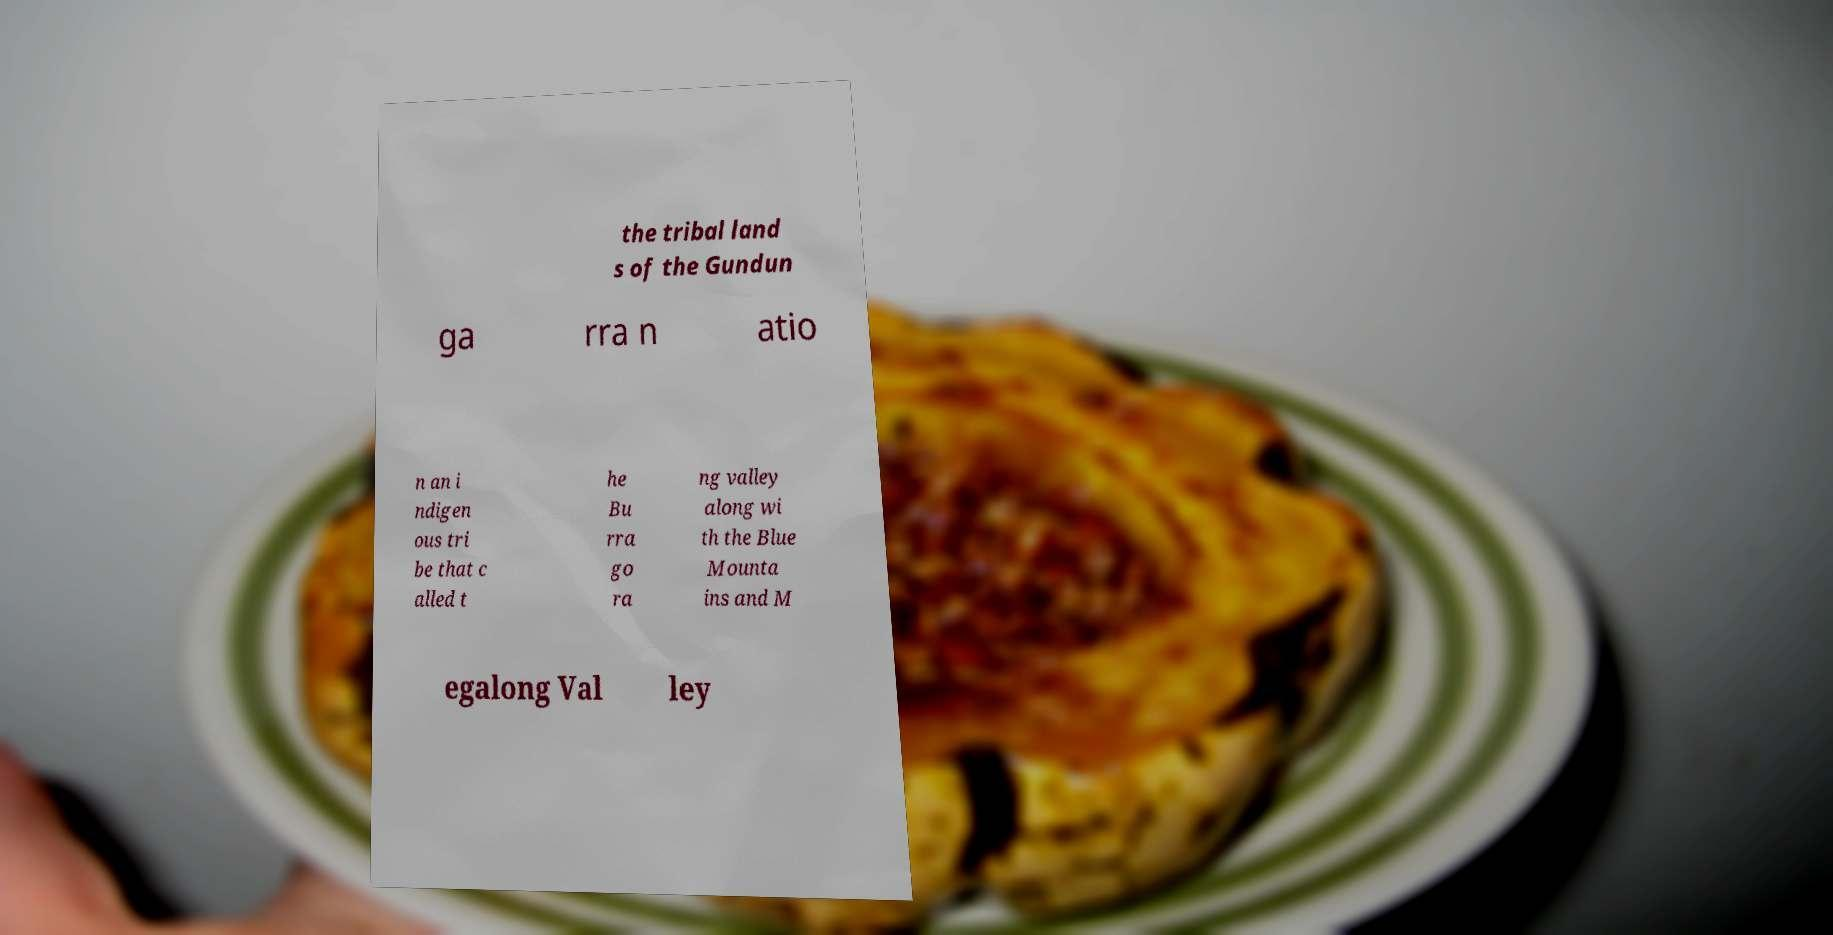Please identify and transcribe the text found in this image. the tribal land s of the Gundun ga rra n atio n an i ndigen ous tri be that c alled t he Bu rra go ra ng valley along wi th the Blue Mounta ins and M egalong Val ley 